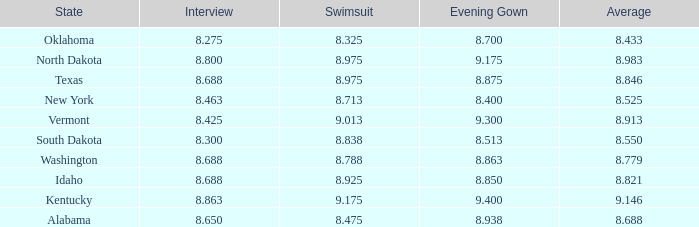What is the lowest average of the contestant with an interview of 8.275 and an evening gown bigger than 8.7? None. 